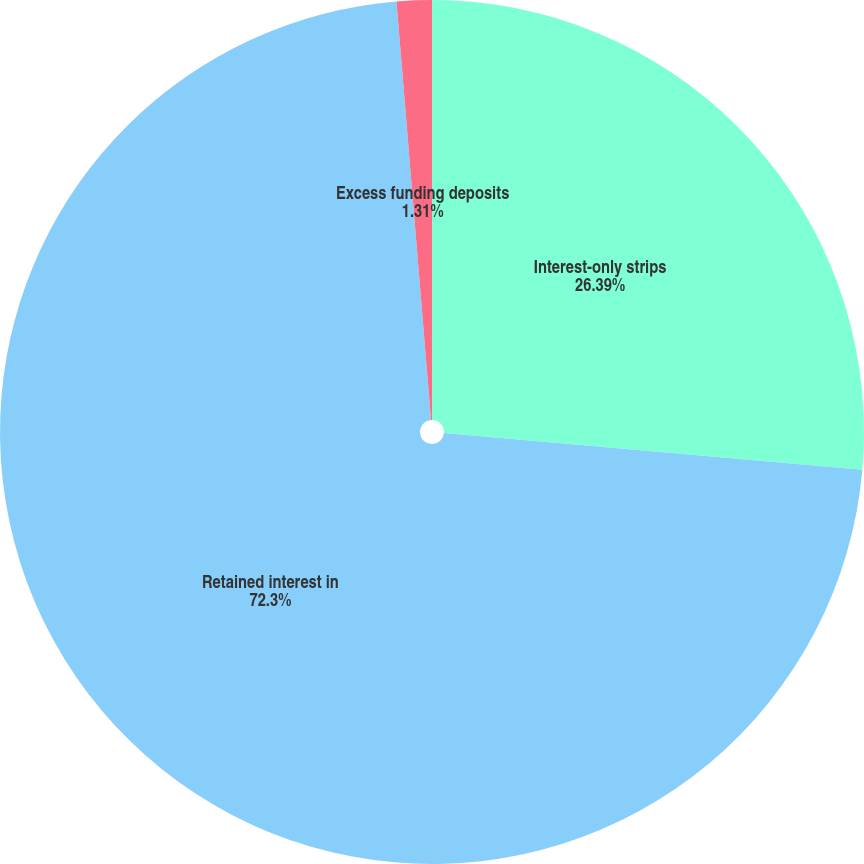<chart> <loc_0><loc_0><loc_500><loc_500><pie_chart><fcel>Interest-only strips<fcel>Retained interest in<fcel>Excess funding deposits<nl><fcel>26.39%<fcel>72.3%<fcel>1.31%<nl></chart> 